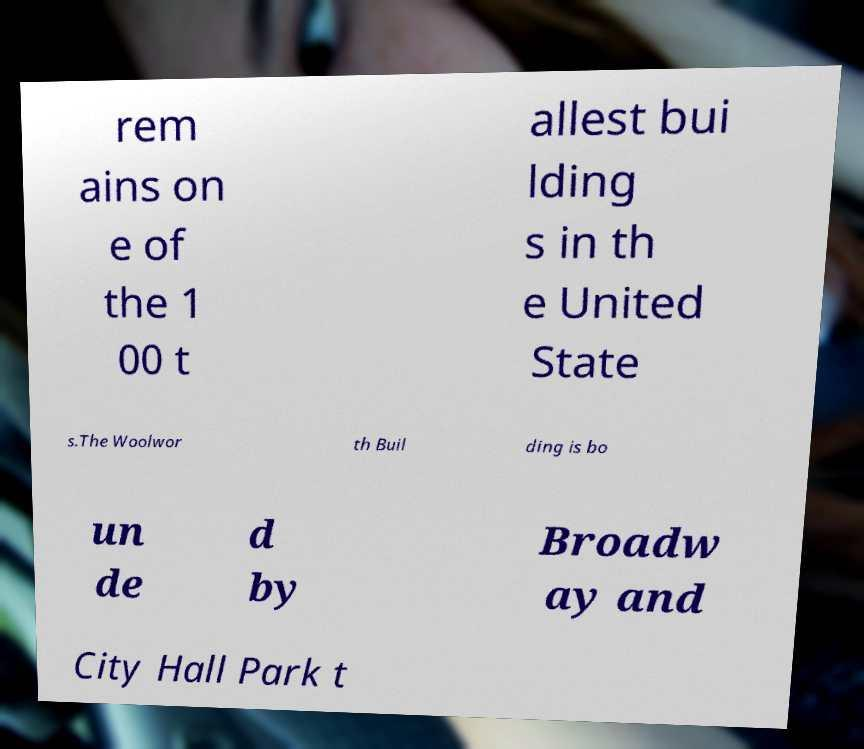Can you read and provide the text displayed in the image?This photo seems to have some interesting text. Can you extract and type it out for me? rem ains on e of the 1 00 t allest bui lding s in th e United State s.The Woolwor th Buil ding is bo un de d by Broadw ay and City Hall Park t 